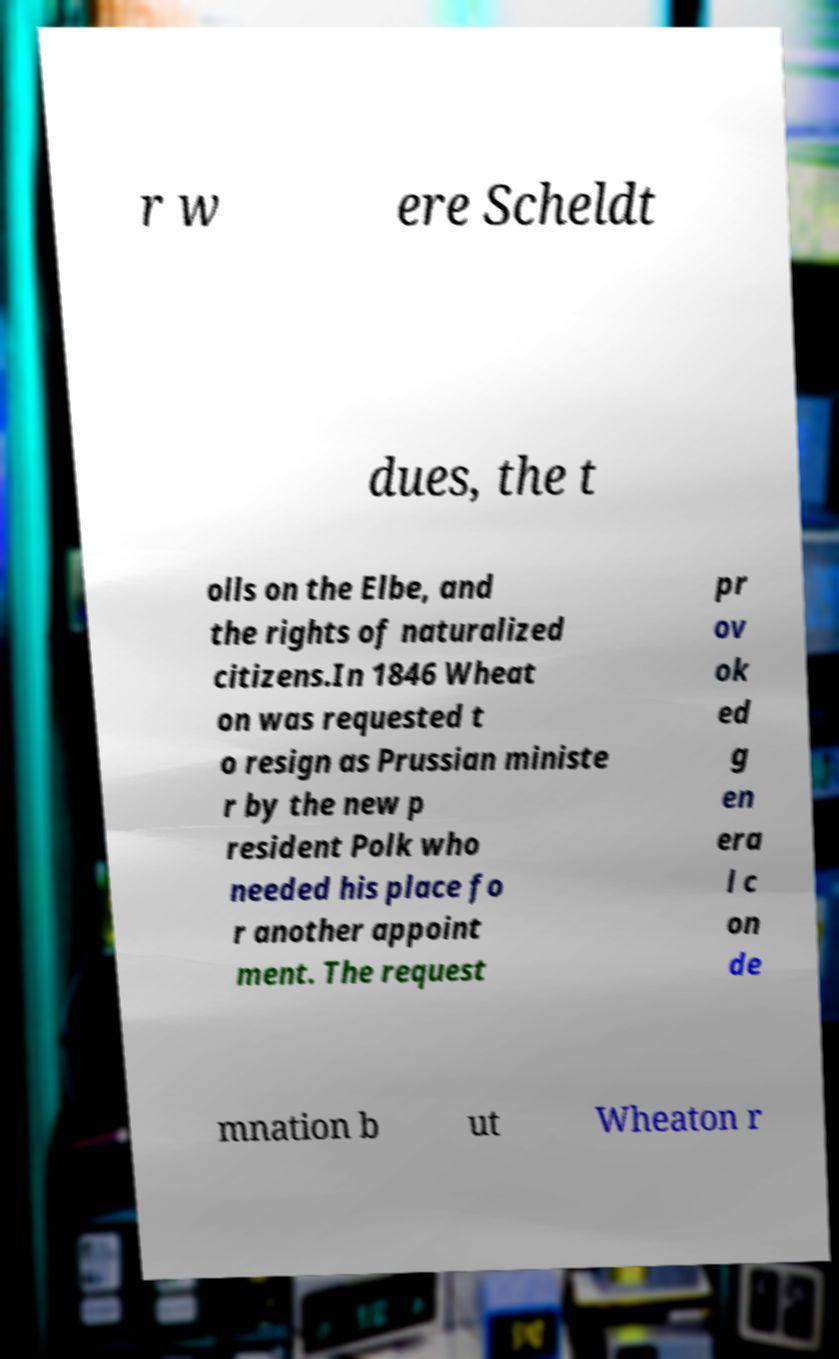Could you extract and type out the text from this image? r w ere Scheldt dues, the t olls on the Elbe, and the rights of naturalized citizens.In 1846 Wheat on was requested t o resign as Prussian ministe r by the new p resident Polk who needed his place fo r another appoint ment. The request pr ov ok ed g en era l c on de mnation b ut Wheaton r 